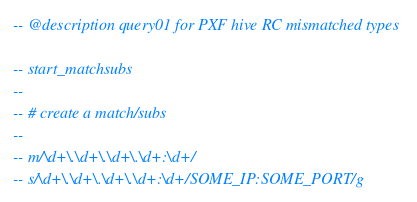Convert code to text. <code><loc_0><loc_0><loc_500><loc_500><_SQL_>-- @description query01 for PXF hive RC mismatched types

-- start_matchsubs
--                                                                                               
-- # create a match/subs
--
-- m/\d+\.\d+\.\d+\.\d+:\d+/
-- s/\d+\.\d+\.\d+\.\d+:\d+/SOME_IP:SOME_PORT/g</code> 